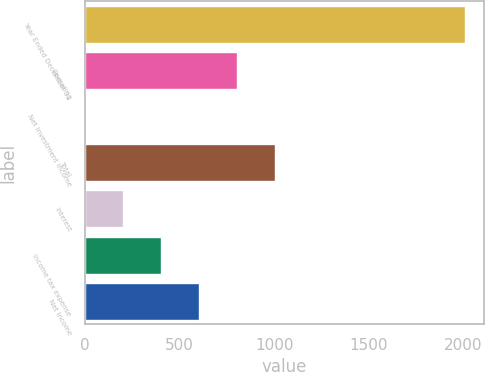Convert chart to OTSL. <chart><loc_0><loc_0><loc_500><loc_500><bar_chart><fcel>Year Ended December 31<fcel>Operating<fcel>Net investment income<fcel>Total<fcel>Interest<fcel>Income tax expense<fcel>Net income<nl><fcel>2007<fcel>804<fcel>2<fcel>1004.5<fcel>202.5<fcel>403<fcel>603.5<nl></chart> 